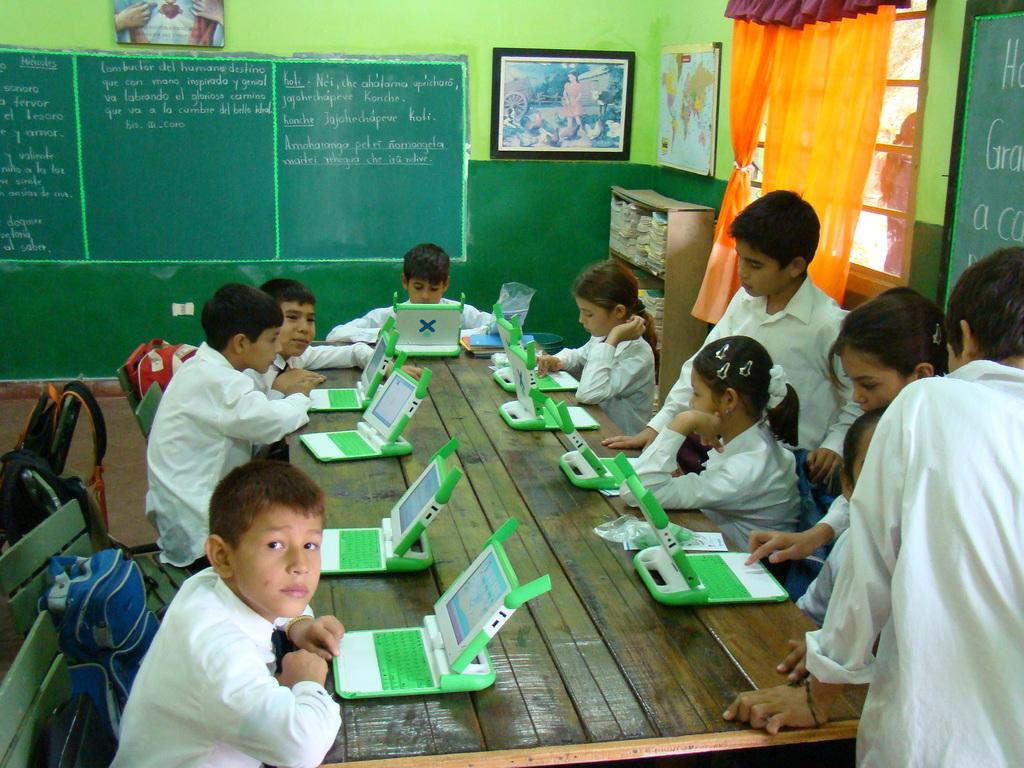Who is present in the image? There are children in the image. What are the children wearing? The children are wearing school dress. What activity are the children engaged in? The children are operating computers. What teaching aid can be seen in the image? There is a blackboard in the image. Where is the son sitting on the throne in the image? There is no son or throne present in the image. What type of cough is the child experiencing in the image? There is no indication of a cough or any illness in the image. 